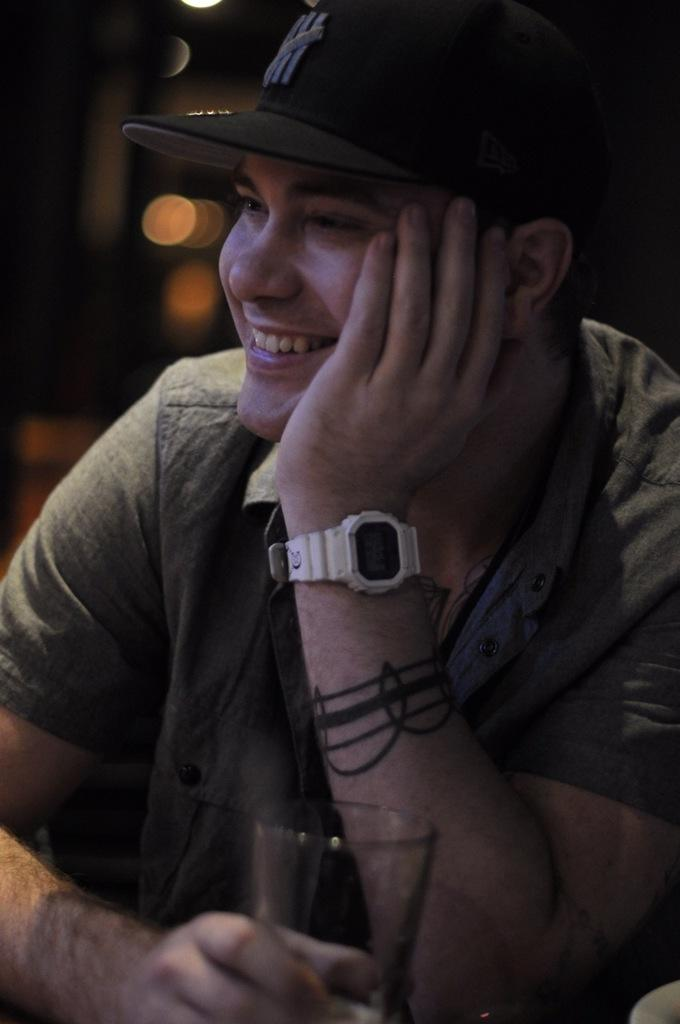Who is present in the image? There is a man in the image. What is the man wearing on his head? The man is wearing a cap. What is the man's facial expression in the image? The man is smiling. What object is in front of the man? There is a glass in front of the man. What type of bridge can be seen in the background of the image? There is no bridge present in the image; it only features a man wearing a cap, smiling, and a glass in front of him. 